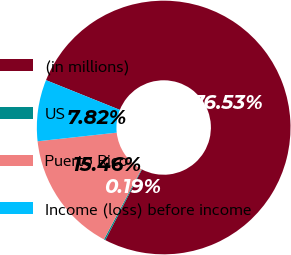<chart> <loc_0><loc_0><loc_500><loc_500><pie_chart><fcel>(in millions)<fcel>US<fcel>Puerto Rico<fcel>Income (loss) before income<nl><fcel>76.53%<fcel>0.19%<fcel>15.46%<fcel>7.82%<nl></chart> 